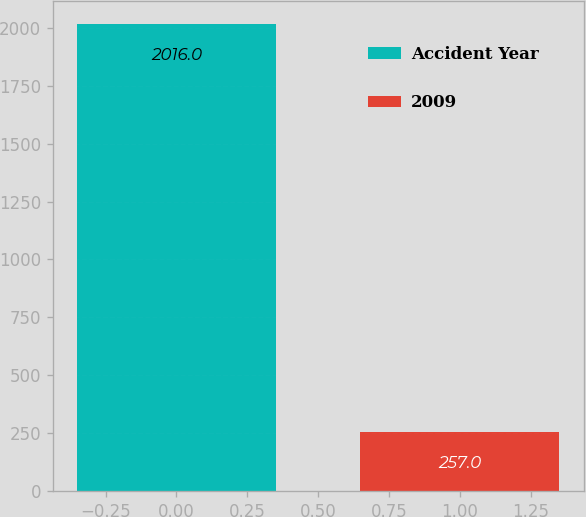Convert chart. <chart><loc_0><loc_0><loc_500><loc_500><bar_chart><fcel>Accident Year<fcel>2009<nl><fcel>2016<fcel>257<nl></chart> 